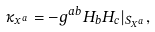Convert formula to latex. <formula><loc_0><loc_0><loc_500><loc_500>\kappa _ { x ^ { a } } = - g ^ { a b } H _ { b } H _ { c } | _ { S _ { X ^ { a } } } ,</formula> 